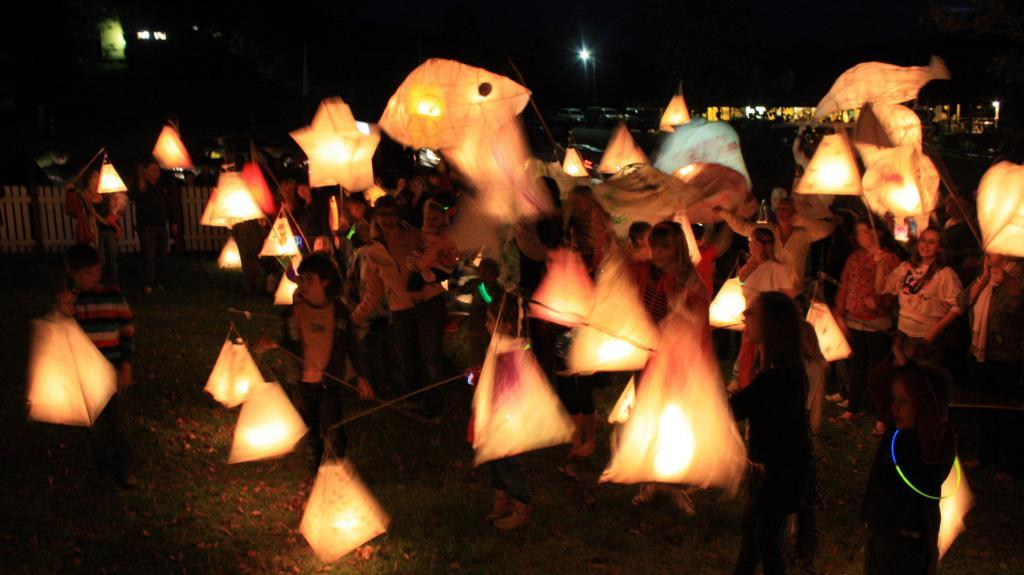What type of kites are featured in the image? There are fire kites in the image. Can you describe the people in the image? There are people in the image, but their specific actions or appearances are not mentioned in the facts. What can be seen near the people in the image? There is railing visible in the image. What else is present in the image besides the kites and people? Lights and vehicles are present in the image. What is the color of the background in the image? The background of the image is black. In which direction are the cent of the fire kites flying in the image? There is no mention of a cent in the image, and the direction of the fire kites is not specified in the facts. Is there any popcorn visible in the image? There is no mention of popcorn in the image. 